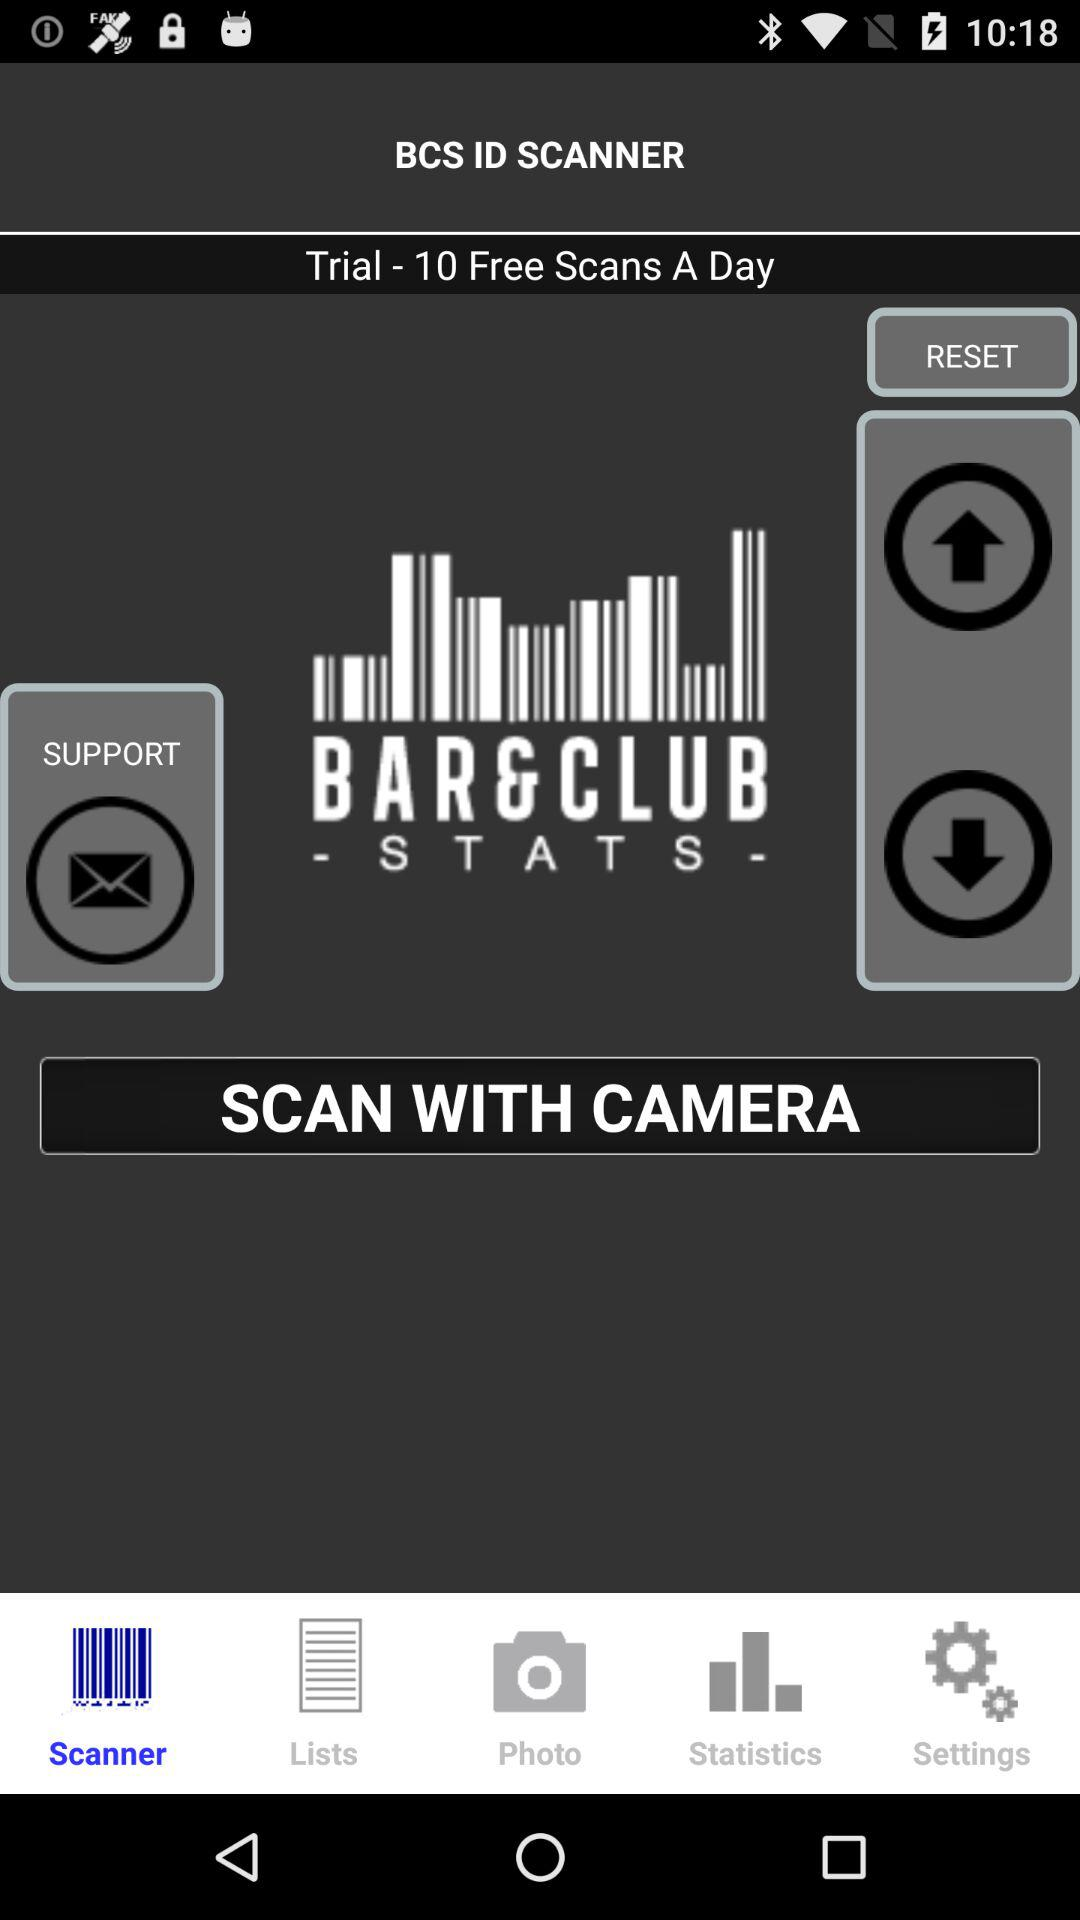Which tab is selected? The selected tab is "Scanner". 